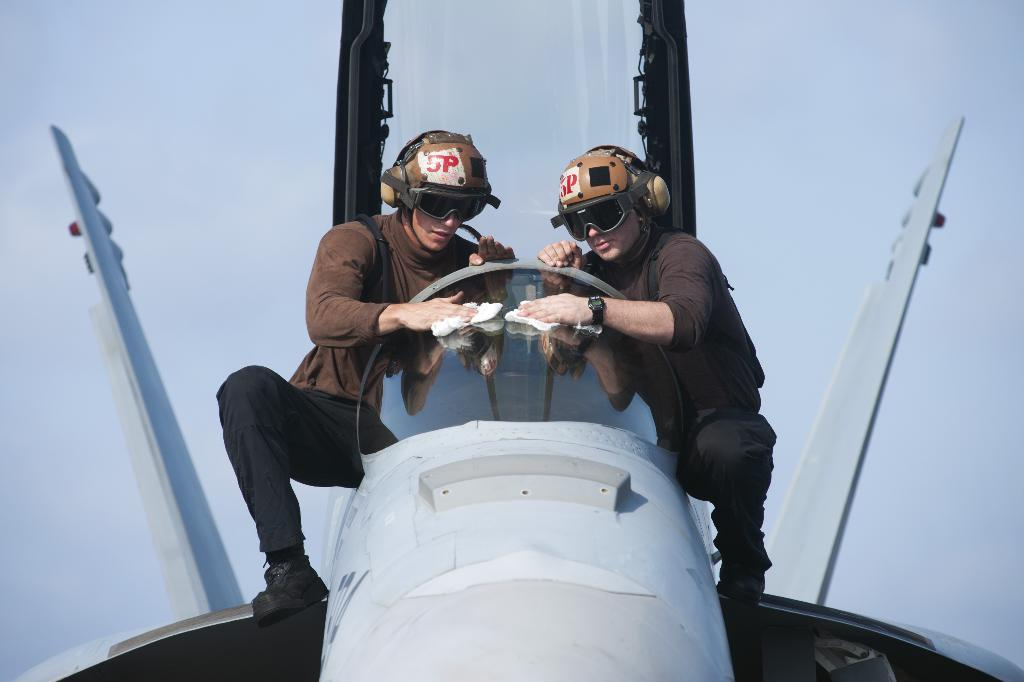What is the main subject in the foreground of the image? There is an airplane in the foreground of the image. What are the two men in the image doing? The men are standing on the airplane and cleaning the glass. What tool are the men using for cleaning? The men are using a white-colored cloth for cleaning. What can be seen in the background of the image? The sky is visible in the background of the image. What type of whip can be seen in the hands of the men in the image? There is no whip present in the image; the men are using a white-colored cloth for cleaning. What event is taking place in the image? The image does not depict a specific event; it shows two men cleaning the glass of an airplane. 